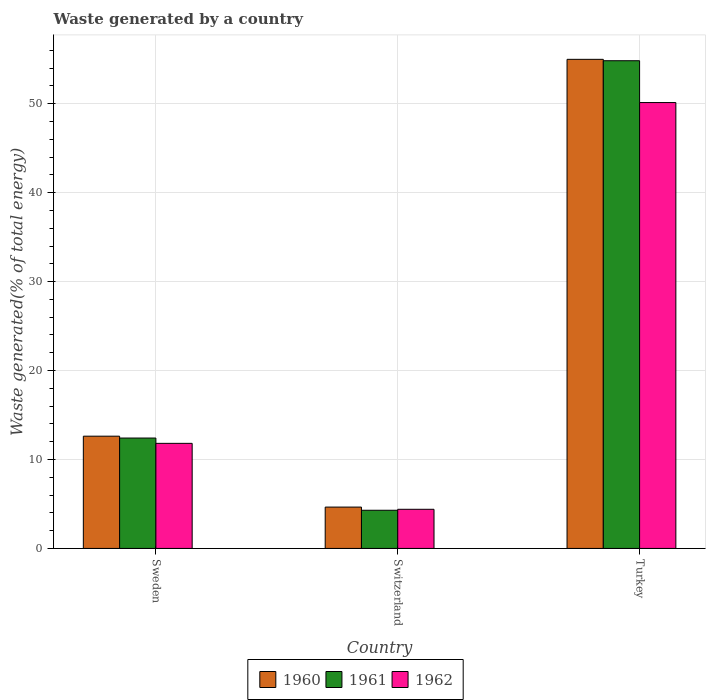Are the number of bars per tick equal to the number of legend labels?
Provide a succinct answer. Yes. How many bars are there on the 2nd tick from the left?
Provide a short and direct response. 3. What is the total waste generated in 1960 in Switzerland?
Offer a very short reply. 4.65. Across all countries, what is the maximum total waste generated in 1961?
Give a very brief answer. 54.84. Across all countries, what is the minimum total waste generated in 1961?
Provide a succinct answer. 4.29. In which country was the total waste generated in 1960 minimum?
Your answer should be compact. Switzerland. What is the total total waste generated in 1962 in the graph?
Your answer should be very brief. 66.35. What is the difference between the total waste generated in 1962 in Sweden and that in Switzerland?
Offer a terse response. 7.41. What is the difference between the total waste generated in 1962 in Sweden and the total waste generated in 1961 in Turkey?
Keep it short and to the point. -43.02. What is the average total waste generated in 1961 per country?
Offer a very short reply. 23.85. What is the difference between the total waste generated of/in 1962 and total waste generated of/in 1960 in Turkey?
Make the answer very short. -4.86. In how many countries, is the total waste generated in 1962 greater than 34 %?
Offer a very short reply. 1. What is the ratio of the total waste generated in 1960 in Switzerland to that in Turkey?
Provide a succinct answer. 0.08. Is the total waste generated in 1962 in Sweden less than that in Turkey?
Give a very brief answer. Yes. Is the difference between the total waste generated in 1962 in Switzerland and Turkey greater than the difference between the total waste generated in 1960 in Switzerland and Turkey?
Your answer should be very brief. Yes. What is the difference between the highest and the second highest total waste generated in 1962?
Give a very brief answer. 38.32. What is the difference between the highest and the lowest total waste generated in 1961?
Your response must be concise. 50.55. What does the 3rd bar from the right in Sweden represents?
Make the answer very short. 1960. How many bars are there?
Ensure brevity in your answer.  9. What is the difference between two consecutive major ticks on the Y-axis?
Your response must be concise. 10. Does the graph contain any zero values?
Ensure brevity in your answer.  No. Where does the legend appear in the graph?
Give a very brief answer. Bottom center. How many legend labels are there?
Ensure brevity in your answer.  3. What is the title of the graph?
Your answer should be compact. Waste generated by a country. What is the label or title of the Y-axis?
Give a very brief answer. Waste generated(% of total energy). What is the Waste generated(% of total energy) in 1960 in Sweden?
Your answer should be compact. 12.62. What is the Waste generated(% of total energy) in 1961 in Sweden?
Your answer should be very brief. 12.41. What is the Waste generated(% of total energy) of 1962 in Sweden?
Give a very brief answer. 11.82. What is the Waste generated(% of total energy) in 1960 in Switzerland?
Provide a short and direct response. 4.65. What is the Waste generated(% of total energy) of 1961 in Switzerland?
Make the answer very short. 4.29. What is the Waste generated(% of total energy) in 1962 in Switzerland?
Your answer should be very brief. 4.4. What is the Waste generated(% of total energy) of 1960 in Turkey?
Provide a short and direct response. 54.99. What is the Waste generated(% of total energy) of 1961 in Turkey?
Your answer should be compact. 54.84. What is the Waste generated(% of total energy) in 1962 in Turkey?
Provide a succinct answer. 50.13. Across all countries, what is the maximum Waste generated(% of total energy) of 1960?
Provide a succinct answer. 54.99. Across all countries, what is the maximum Waste generated(% of total energy) of 1961?
Offer a terse response. 54.84. Across all countries, what is the maximum Waste generated(% of total energy) of 1962?
Your response must be concise. 50.13. Across all countries, what is the minimum Waste generated(% of total energy) of 1960?
Your answer should be compact. 4.65. Across all countries, what is the minimum Waste generated(% of total energy) of 1961?
Offer a terse response. 4.29. Across all countries, what is the minimum Waste generated(% of total energy) of 1962?
Your response must be concise. 4.4. What is the total Waste generated(% of total energy) in 1960 in the graph?
Offer a terse response. 72.27. What is the total Waste generated(% of total energy) in 1961 in the graph?
Your answer should be very brief. 71.54. What is the total Waste generated(% of total energy) in 1962 in the graph?
Give a very brief answer. 66.35. What is the difference between the Waste generated(% of total energy) in 1960 in Sweden and that in Switzerland?
Offer a terse response. 7.97. What is the difference between the Waste generated(% of total energy) in 1961 in Sweden and that in Switzerland?
Provide a short and direct response. 8.12. What is the difference between the Waste generated(% of total energy) of 1962 in Sweden and that in Switzerland?
Offer a very short reply. 7.41. What is the difference between the Waste generated(% of total energy) of 1960 in Sweden and that in Turkey?
Keep it short and to the point. -42.37. What is the difference between the Waste generated(% of total energy) in 1961 in Sweden and that in Turkey?
Your answer should be very brief. -42.43. What is the difference between the Waste generated(% of total energy) in 1962 in Sweden and that in Turkey?
Your response must be concise. -38.32. What is the difference between the Waste generated(% of total energy) in 1960 in Switzerland and that in Turkey?
Your response must be concise. -50.34. What is the difference between the Waste generated(% of total energy) in 1961 in Switzerland and that in Turkey?
Ensure brevity in your answer.  -50.55. What is the difference between the Waste generated(% of total energy) in 1962 in Switzerland and that in Turkey?
Give a very brief answer. -45.73. What is the difference between the Waste generated(% of total energy) in 1960 in Sweden and the Waste generated(% of total energy) in 1961 in Switzerland?
Offer a very short reply. 8.33. What is the difference between the Waste generated(% of total energy) of 1960 in Sweden and the Waste generated(% of total energy) of 1962 in Switzerland?
Your answer should be very brief. 8.22. What is the difference between the Waste generated(% of total energy) of 1961 in Sweden and the Waste generated(% of total energy) of 1962 in Switzerland?
Make the answer very short. 8.01. What is the difference between the Waste generated(% of total energy) in 1960 in Sweden and the Waste generated(% of total energy) in 1961 in Turkey?
Keep it short and to the point. -42.22. What is the difference between the Waste generated(% of total energy) in 1960 in Sweden and the Waste generated(% of total energy) in 1962 in Turkey?
Offer a terse response. -37.51. What is the difference between the Waste generated(% of total energy) of 1961 in Sweden and the Waste generated(% of total energy) of 1962 in Turkey?
Give a very brief answer. -37.72. What is the difference between the Waste generated(% of total energy) in 1960 in Switzerland and the Waste generated(% of total energy) in 1961 in Turkey?
Ensure brevity in your answer.  -50.19. What is the difference between the Waste generated(% of total energy) of 1960 in Switzerland and the Waste generated(% of total energy) of 1962 in Turkey?
Provide a succinct answer. -45.48. What is the difference between the Waste generated(% of total energy) in 1961 in Switzerland and the Waste generated(% of total energy) in 1962 in Turkey?
Provide a short and direct response. -45.84. What is the average Waste generated(% of total energy) in 1960 per country?
Your answer should be compact. 24.09. What is the average Waste generated(% of total energy) in 1961 per country?
Make the answer very short. 23.85. What is the average Waste generated(% of total energy) of 1962 per country?
Offer a terse response. 22.12. What is the difference between the Waste generated(% of total energy) in 1960 and Waste generated(% of total energy) in 1961 in Sweden?
Provide a succinct answer. 0.21. What is the difference between the Waste generated(% of total energy) in 1960 and Waste generated(% of total energy) in 1962 in Sweden?
Give a very brief answer. 0.81. What is the difference between the Waste generated(% of total energy) in 1961 and Waste generated(% of total energy) in 1962 in Sweden?
Provide a succinct answer. 0.6. What is the difference between the Waste generated(% of total energy) of 1960 and Waste generated(% of total energy) of 1961 in Switzerland?
Your answer should be very brief. 0.36. What is the difference between the Waste generated(% of total energy) of 1960 and Waste generated(% of total energy) of 1962 in Switzerland?
Give a very brief answer. 0.25. What is the difference between the Waste generated(% of total energy) of 1961 and Waste generated(% of total energy) of 1962 in Switzerland?
Your answer should be compact. -0.11. What is the difference between the Waste generated(% of total energy) of 1960 and Waste generated(% of total energy) of 1961 in Turkey?
Your answer should be compact. 0.16. What is the difference between the Waste generated(% of total energy) in 1960 and Waste generated(% of total energy) in 1962 in Turkey?
Provide a short and direct response. 4.86. What is the difference between the Waste generated(% of total energy) of 1961 and Waste generated(% of total energy) of 1962 in Turkey?
Provide a short and direct response. 4.7. What is the ratio of the Waste generated(% of total energy) of 1960 in Sweden to that in Switzerland?
Offer a very short reply. 2.71. What is the ratio of the Waste generated(% of total energy) of 1961 in Sweden to that in Switzerland?
Your answer should be compact. 2.89. What is the ratio of the Waste generated(% of total energy) in 1962 in Sweden to that in Switzerland?
Your answer should be compact. 2.68. What is the ratio of the Waste generated(% of total energy) in 1960 in Sweden to that in Turkey?
Make the answer very short. 0.23. What is the ratio of the Waste generated(% of total energy) of 1961 in Sweden to that in Turkey?
Your answer should be compact. 0.23. What is the ratio of the Waste generated(% of total energy) in 1962 in Sweden to that in Turkey?
Make the answer very short. 0.24. What is the ratio of the Waste generated(% of total energy) of 1960 in Switzerland to that in Turkey?
Give a very brief answer. 0.08. What is the ratio of the Waste generated(% of total energy) of 1961 in Switzerland to that in Turkey?
Your response must be concise. 0.08. What is the ratio of the Waste generated(% of total energy) of 1962 in Switzerland to that in Turkey?
Provide a short and direct response. 0.09. What is the difference between the highest and the second highest Waste generated(% of total energy) of 1960?
Provide a short and direct response. 42.37. What is the difference between the highest and the second highest Waste generated(% of total energy) in 1961?
Your answer should be compact. 42.43. What is the difference between the highest and the second highest Waste generated(% of total energy) in 1962?
Ensure brevity in your answer.  38.32. What is the difference between the highest and the lowest Waste generated(% of total energy) in 1960?
Offer a terse response. 50.34. What is the difference between the highest and the lowest Waste generated(% of total energy) in 1961?
Offer a very short reply. 50.55. What is the difference between the highest and the lowest Waste generated(% of total energy) in 1962?
Offer a terse response. 45.73. 